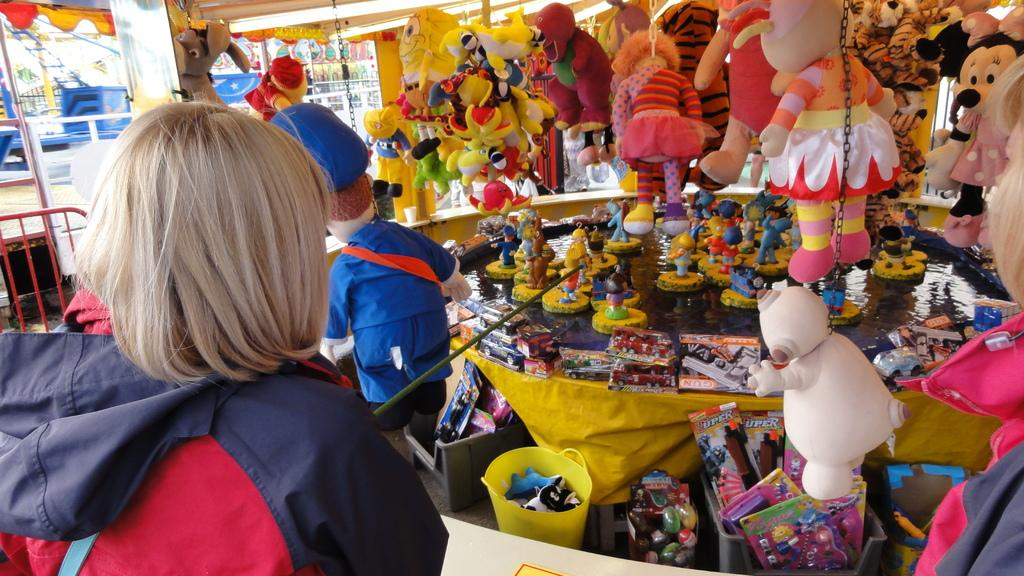What type of items can be seen in the image? The image contains many teddies and toys. Where might this image have been taken? The setting appears to be a shop. Can you describe the woman in the image? The woman is wearing a red jacket and holding a stick. What is located at the bottom of the image? There is a table at the bottom of the image. What type of carriage can be seen in the image? There is no carriage present in the image. What is the ground made of in the image? The image does not show the ground, so it cannot be determined what it is made of. 